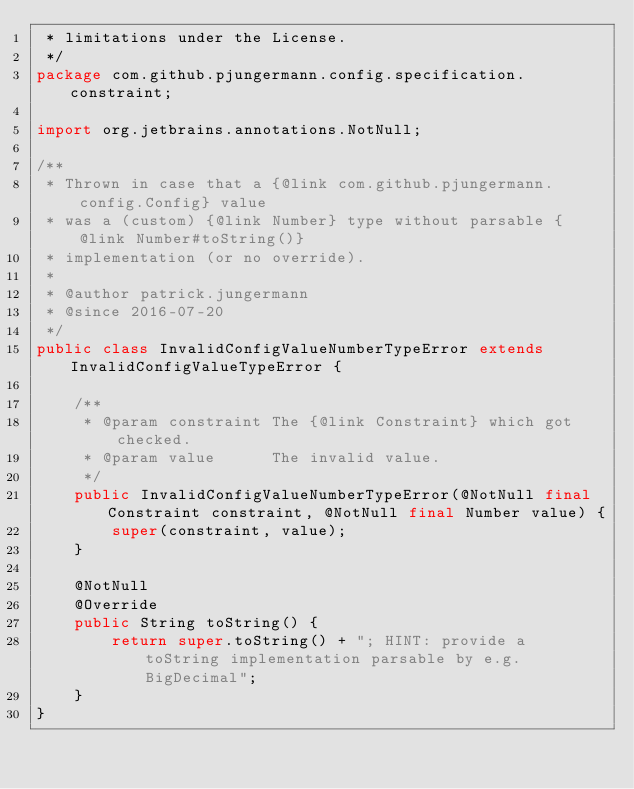<code> <loc_0><loc_0><loc_500><loc_500><_Java_> * limitations under the License.
 */
package com.github.pjungermann.config.specification.constraint;

import org.jetbrains.annotations.NotNull;

/**
 * Thrown in case that a {@link com.github.pjungermann.config.Config} value
 * was a (custom) {@link Number} type without parsable {@link Number#toString()}
 * implementation (or no override).
 *
 * @author patrick.jungermann
 * @since 2016-07-20
 */
public class InvalidConfigValueNumberTypeError extends InvalidConfigValueTypeError {

    /**
     * @param constraint The {@link Constraint} which got checked.
     * @param value      The invalid value.
     */
    public InvalidConfigValueNumberTypeError(@NotNull final Constraint constraint, @NotNull final Number value) {
        super(constraint, value);
    }

    @NotNull
    @Override
    public String toString() {
        return super.toString() + "; HINT: provide a toString implementation parsable by e.g. BigDecimal";
    }
}
</code> 